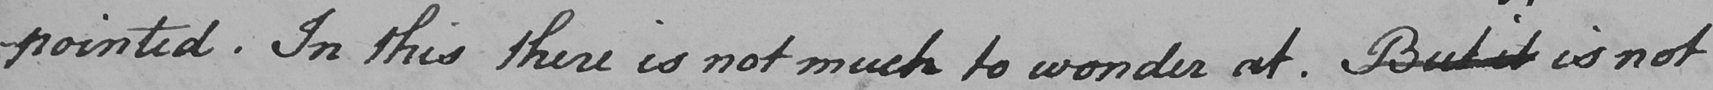Transcribe the text shown in this historical manuscript line. -pointed In this there is not much to wonder at . But it is not 